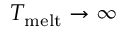Convert formula to latex. <formula><loc_0><loc_0><loc_500><loc_500>T _ { m e l t } \rightarrow \infty</formula> 